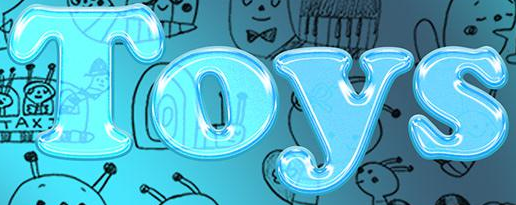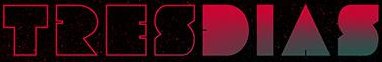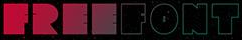What words can you see in these images in sequence, separated by a semicolon? Toys; TRESDIAS; FREEFONT 